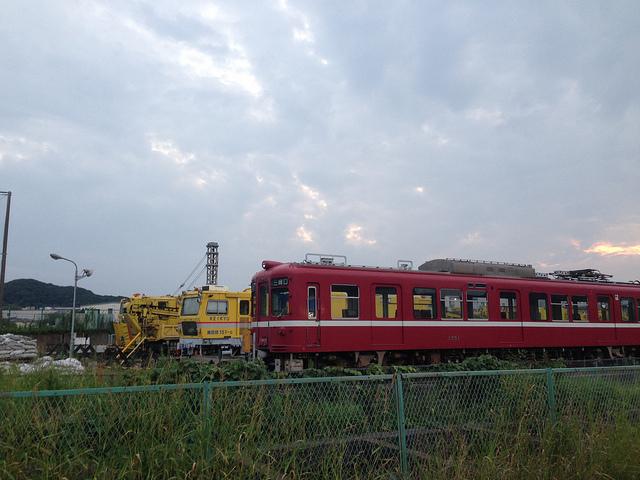What is the name of the train?
Write a very short answer. None. What is behind the train?
Give a very brief answer. Another train. Is the train in locomotion?
Give a very brief answer. No. Is there smoke in the picture?
Short answer required. No. How many trains are in the photo?
Concise answer only. 1. Are the train windows open?
Keep it brief. Yes. Where is the locomotive?
Keep it brief. Tracks. What color is the grass pictured?
Give a very brief answer. Green. What color are the last train cars?
Be succinct. Red. Does the train have lights?
Concise answer only. No. Is it night?
Answer briefly. No. What time of the day it is?
Write a very short answer. Afternoon. Is it a sunny or cloudy day?
Give a very brief answer. Cloudy. What is the fence made of?
Concise answer only. Metal. Does this train look like it is moving?
Answer briefly. No. Is the train moving?
Answer briefly. No. Can you see inside the train?
Concise answer only. Yes. What color are the doors on the train?
Be succinct. Red. Is this a city area?
Answer briefly. No. Is this an old train?
Quick response, please. Yes. What color is the letter on the train?
Keep it brief. Black. How many train carts do you see?
Keep it brief. 2. What color is the front of the train?
Short answer required. Red. What kind of vehicle is this?
Short answer required. Train. Who manufactured this train car?
Give a very brief answer. Union pacific. How many different color style are on each of thes buses?
Quick response, please. 2. Is this train blue?
Quick response, please. No. Are the trains going in the same direction?
Give a very brief answer. Yes. Is there more than one boxcar?
Keep it brief. Yes. What is the color of the train's stripes?
Keep it brief. White. Why can you see two trains?
Give a very brief answer. Different tracks. What two colors are present on the train car?
Concise answer only. Red and white. What color is the train?
Quick response, please. Red. Is the train coming towards the camera?
Quick response, please. No. How many trains are there?
Concise answer only. 2. How many colors are on the train?
Be succinct. 2. Where is the train?
Keep it brief. Repair yard. What is the train traveling on?
Give a very brief answer. Tracks. How many train cars are in the picture?
Answer briefly. 1. Is there train tracks in this picture?
Write a very short answer. No. What color is the chain?
Be succinct. Green. Is this a real train?
Give a very brief answer. Yes. Is this a black and white picture?
Give a very brief answer. No. Is the train in motion?
Keep it brief. No. How many trains are in the picture?
Keep it brief. 1. What is the train on?
Keep it brief. Track. Where was the scene photographed?
Keep it brief. Train station. How many trains are on the track?
Quick response, please. 1. 